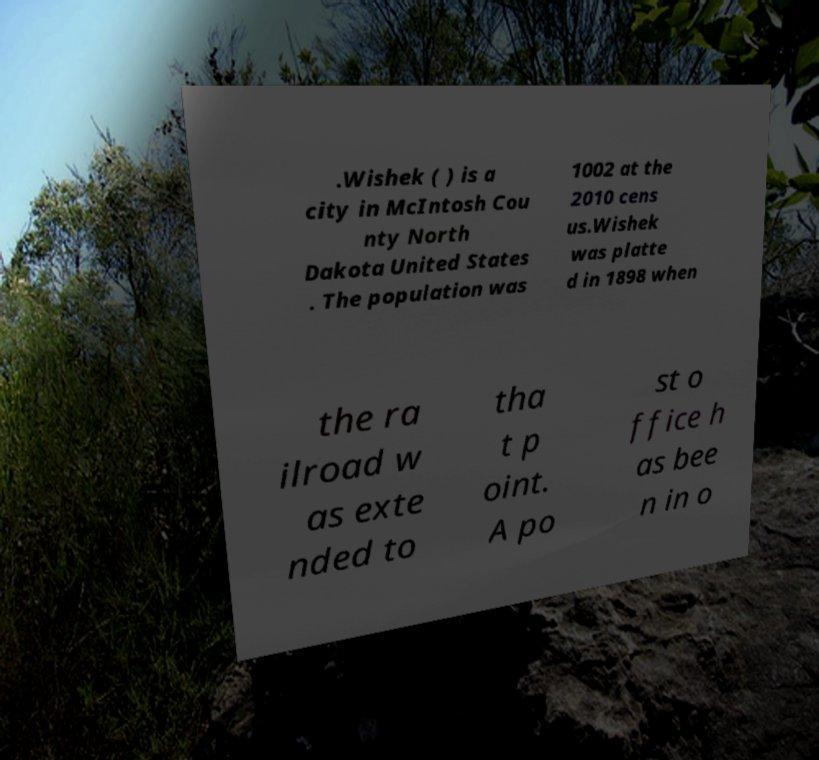Can you read and provide the text displayed in the image?This photo seems to have some interesting text. Can you extract and type it out for me? .Wishek ( ) is a city in McIntosh Cou nty North Dakota United States . The population was 1002 at the 2010 cens us.Wishek was platte d in 1898 when the ra ilroad w as exte nded to tha t p oint. A po st o ffice h as bee n in o 